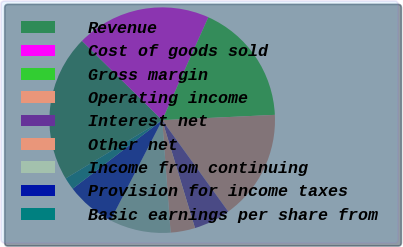<chart> <loc_0><loc_0><loc_500><loc_500><pie_chart><fcel>Revenue<fcel>Cost of goods sold<fcel>Gross margin<fcel>Operating income<fcel>Interest net<fcel>Other net<fcel>Income from continuing<fcel>Provision for income taxes<fcel>Basic earnings per share from<nl><fcel>21.05%<fcel>19.3%<fcel>17.54%<fcel>15.79%<fcel>5.26%<fcel>3.51%<fcel>8.77%<fcel>7.02%<fcel>1.75%<nl></chart> 